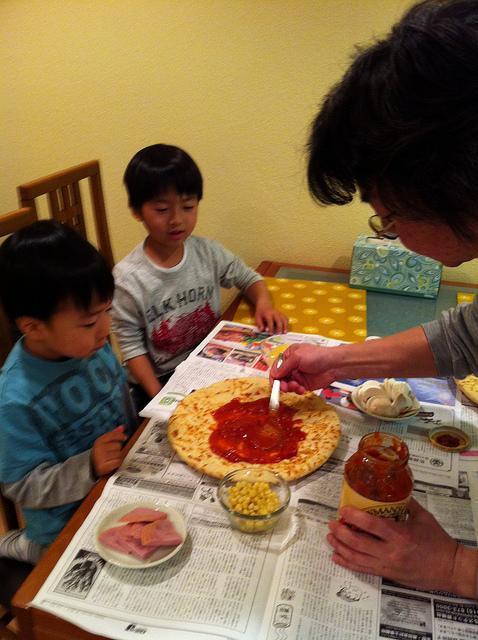How many pizzas are there?
Give a very brief answer. 1. How many bowls can you see?
Give a very brief answer. 2. How many people are there?
Give a very brief answer. 3. How many horses look different than the others?
Give a very brief answer. 0. 